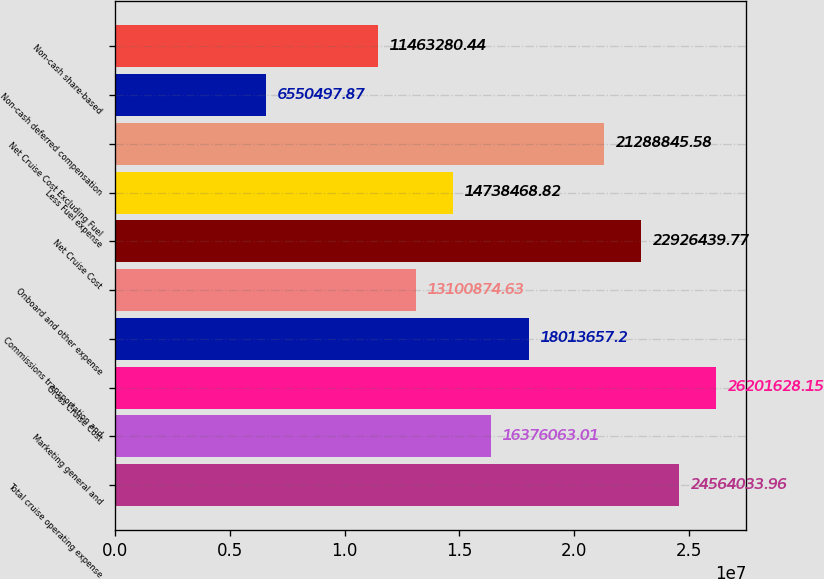Convert chart. <chart><loc_0><loc_0><loc_500><loc_500><bar_chart><fcel>Total cruise operating expense<fcel>Marketing general and<fcel>Gross Cruise Cost<fcel>Commissions transportation and<fcel>Onboard and other expense<fcel>Net Cruise Cost<fcel>Less Fuel expense<fcel>Net Cruise Cost Excluding Fuel<fcel>Non-cash deferred compensation<fcel>Non-cash share-based<nl><fcel>2.4564e+07<fcel>1.63761e+07<fcel>2.62016e+07<fcel>1.80137e+07<fcel>1.31009e+07<fcel>2.29264e+07<fcel>1.47385e+07<fcel>2.12888e+07<fcel>6.5505e+06<fcel>1.14633e+07<nl></chart> 